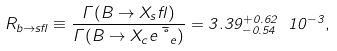Convert formula to latex. <formula><loc_0><loc_0><loc_500><loc_500>R _ { b \rightarrow s \gamma } \equiv \frac { \Gamma ( B \rightarrow X _ { s } \gamma ) } { \Gamma ( B \rightarrow X _ { c } e \bar { \nu } _ { e } ) } = 3 . 3 9 _ { - 0 . 5 4 } ^ { + 0 . 6 2 } \ 1 0 ^ { - 3 } ,</formula> 